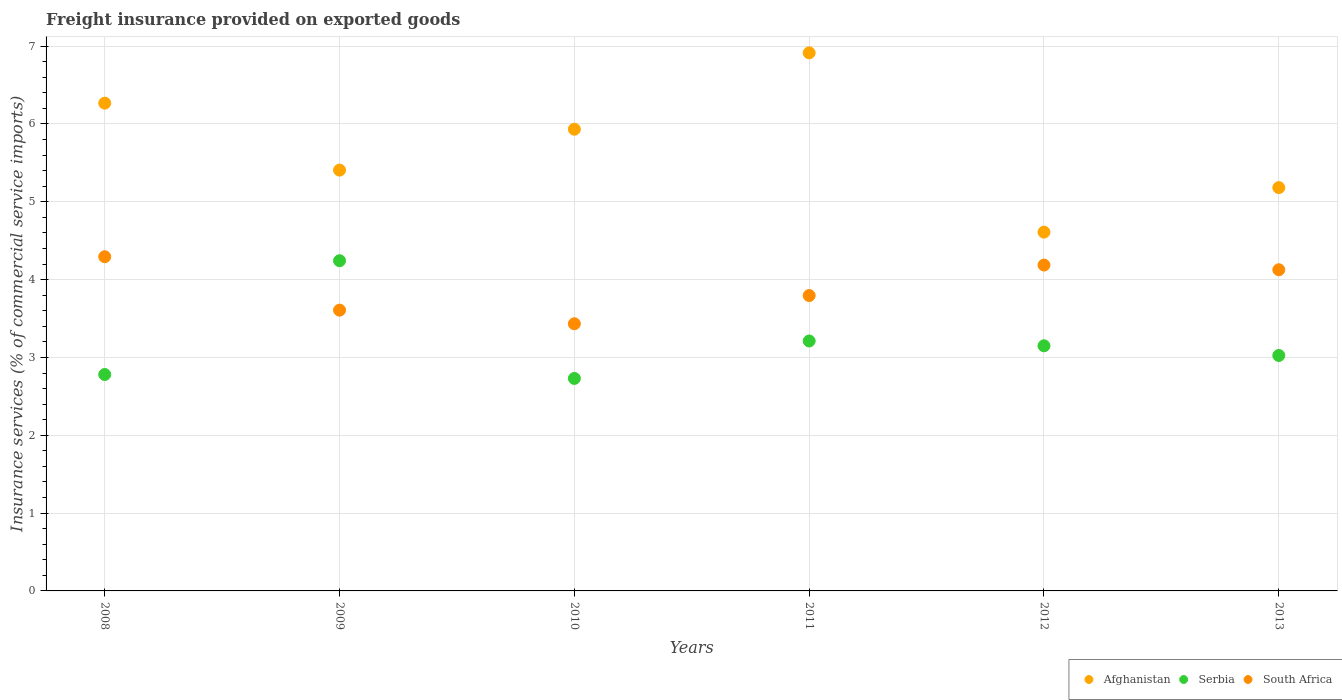What is the freight insurance provided on exported goods in Serbia in 2013?
Your response must be concise. 3.03. Across all years, what is the maximum freight insurance provided on exported goods in South Africa?
Keep it short and to the point. 4.29. Across all years, what is the minimum freight insurance provided on exported goods in South Africa?
Your response must be concise. 3.43. In which year was the freight insurance provided on exported goods in Afghanistan maximum?
Make the answer very short. 2011. What is the total freight insurance provided on exported goods in Serbia in the graph?
Your response must be concise. 19.14. What is the difference between the freight insurance provided on exported goods in Afghanistan in 2009 and that in 2011?
Provide a succinct answer. -1.51. What is the difference between the freight insurance provided on exported goods in South Africa in 2012 and the freight insurance provided on exported goods in Afghanistan in 2008?
Give a very brief answer. -2.08. What is the average freight insurance provided on exported goods in Serbia per year?
Offer a terse response. 3.19. In the year 2008, what is the difference between the freight insurance provided on exported goods in Afghanistan and freight insurance provided on exported goods in South Africa?
Your response must be concise. 1.97. What is the ratio of the freight insurance provided on exported goods in Afghanistan in 2011 to that in 2013?
Your answer should be compact. 1.33. What is the difference between the highest and the second highest freight insurance provided on exported goods in Serbia?
Offer a very short reply. 1.03. What is the difference between the highest and the lowest freight insurance provided on exported goods in South Africa?
Your answer should be compact. 0.86. Is it the case that in every year, the sum of the freight insurance provided on exported goods in Afghanistan and freight insurance provided on exported goods in Serbia  is greater than the freight insurance provided on exported goods in South Africa?
Keep it short and to the point. Yes. Does the freight insurance provided on exported goods in Serbia monotonically increase over the years?
Offer a very short reply. No. Is the freight insurance provided on exported goods in Afghanistan strictly less than the freight insurance provided on exported goods in Serbia over the years?
Give a very brief answer. No. How many dotlines are there?
Ensure brevity in your answer.  3. What is the difference between two consecutive major ticks on the Y-axis?
Provide a succinct answer. 1. Does the graph contain grids?
Keep it short and to the point. Yes. How are the legend labels stacked?
Give a very brief answer. Horizontal. What is the title of the graph?
Offer a very short reply. Freight insurance provided on exported goods. Does "Paraguay" appear as one of the legend labels in the graph?
Ensure brevity in your answer.  No. What is the label or title of the Y-axis?
Ensure brevity in your answer.  Insurance services (% of commercial service imports). What is the Insurance services (% of commercial service imports) of Afghanistan in 2008?
Offer a terse response. 6.27. What is the Insurance services (% of commercial service imports) in Serbia in 2008?
Ensure brevity in your answer.  2.78. What is the Insurance services (% of commercial service imports) of South Africa in 2008?
Your response must be concise. 4.29. What is the Insurance services (% of commercial service imports) of Afghanistan in 2009?
Give a very brief answer. 5.41. What is the Insurance services (% of commercial service imports) of Serbia in 2009?
Provide a succinct answer. 4.24. What is the Insurance services (% of commercial service imports) of South Africa in 2009?
Your response must be concise. 3.61. What is the Insurance services (% of commercial service imports) of Afghanistan in 2010?
Ensure brevity in your answer.  5.93. What is the Insurance services (% of commercial service imports) of Serbia in 2010?
Provide a short and direct response. 2.73. What is the Insurance services (% of commercial service imports) of South Africa in 2010?
Keep it short and to the point. 3.43. What is the Insurance services (% of commercial service imports) of Afghanistan in 2011?
Offer a terse response. 6.91. What is the Insurance services (% of commercial service imports) in Serbia in 2011?
Give a very brief answer. 3.21. What is the Insurance services (% of commercial service imports) in South Africa in 2011?
Your answer should be very brief. 3.8. What is the Insurance services (% of commercial service imports) in Afghanistan in 2012?
Provide a short and direct response. 4.61. What is the Insurance services (% of commercial service imports) of Serbia in 2012?
Give a very brief answer. 3.15. What is the Insurance services (% of commercial service imports) in South Africa in 2012?
Your answer should be compact. 4.19. What is the Insurance services (% of commercial service imports) in Afghanistan in 2013?
Give a very brief answer. 5.18. What is the Insurance services (% of commercial service imports) in Serbia in 2013?
Your answer should be very brief. 3.03. What is the Insurance services (% of commercial service imports) of South Africa in 2013?
Provide a short and direct response. 4.13. Across all years, what is the maximum Insurance services (% of commercial service imports) in Afghanistan?
Your answer should be very brief. 6.91. Across all years, what is the maximum Insurance services (% of commercial service imports) in Serbia?
Provide a short and direct response. 4.24. Across all years, what is the maximum Insurance services (% of commercial service imports) of South Africa?
Make the answer very short. 4.29. Across all years, what is the minimum Insurance services (% of commercial service imports) in Afghanistan?
Offer a terse response. 4.61. Across all years, what is the minimum Insurance services (% of commercial service imports) of Serbia?
Your answer should be compact. 2.73. Across all years, what is the minimum Insurance services (% of commercial service imports) in South Africa?
Provide a short and direct response. 3.43. What is the total Insurance services (% of commercial service imports) in Afghanistan in the graph?
Make the answer very short. 34.31. What is the total Insurance services (% of commercial service imports) in Serbia in the graph?
Your response must be concise. 19.14. What is the total Insurance services (% of commercial service imports) of South Africa in the graph?
Provide a succinct answer. 23.44. What is the difference between the Insurance services (% of commercial service imports) of Afghanistan in 2008 and that in 2009?
Provide a succinct answer. 0.86. What is the difference between the Insurance services (% of commercial service imports) in Serbia in 2008 and that in 2009?
Provide a succinct answer. -1.46. What is the difference between the Insurance services (% of commercial service imports) of South Africa in 2008 and that in 2009?
Your response must be concise. 0.69. What is the difference between the Insurance services (% of commercial service imports) in Afghanistan in 2008 and that in 2010?
Your answer should be compact. 0.34. What is the difference between the Insurance services (% of commercial service imports) of Serbia in 2008 and that in 2010?
Provide a short and direct response. 0.05. What is the difference between the Insurance services (% of commercial service imports) in South Africa in 2008 and that in 2010?
Provide a succinct answer. 0.86. What is the difference between the Insurance services (% of commercial service imports) of Afghanistan in 2008 and that in 2011?
Ensure brevity in your answer.  -0.65. What is the difference between the Insurance services (% of commercial service imports) in Serbia in 2008 and that in 2011?
Your response must be concise. -0.43. What is the difference between the Insurance services (% of commercial service imports) in South Africa in 2008 and that in 2011?
Your answer should be compact. 0.5. What is the difference between the Insurance services (% of commercial service imports) of Afghanistan in 2008 and that in 2012?
Your answer should be compact. 1.66. What is the difference between the Insurance services (% of commercial service imports) of Serbia in 2008 and that in 2012?
Your answer should be very brief. -0.37. What is the difference between the Insurance services (% of commercial service imports) in South Africa in 2008 and that in 2012?
Make the answer very short. 0.11. What is the difference between the Insurance services (% of commercial service imports) of Afghanistan in 2008 and that in 2013?
Give a very brief answer. 1.09. What is the difference between the Insurance services (% of commercial service imports) of Serbia in 2008 and that in 2013?
Your response must be concise. -0.24. What is the difference between the Insurance services (% of commercial service imports) of South Africa in 2008 and that in 2013?
Ensure brevity in your answer.  0.17. What is the difference between the Insurance services (% of commercial service imports) in Afghanistan in 2009 and that in 2010?
Your answer should be compact. -0.53. What is the difference between the Insurance services (% of commercial service imports) in Serbia in 2009 and that in 2010?
Ensure brevity in your answer.  1.51. What is the difference between the Insurance services (% of commercial service imports) of South Africa in 2009 and that in 2010?
Your answer should be compact. 0.17. What is the difference between the Insurance services (% of commercial service imports) of Afghanistan in 2009 and that in 2011?
Provide a short and direct response. -1.51. What is the difference between the Insurance services (% of commercial service imports) of Serbia in 2009 and that in 2011?
Offer a terse response. 1.03. What is the difference between the Insurance services (% of commercial service imports) in South Africa in 2009 and that in 2011?
Provide a succinct answer. -0.19. What is the difference between the Insurance services (% of commercial service imports) in Afghanistan in 2009 and that in 2012?
Your answer should be compact. 0.8. What is the difference between the Insurance services (% of commercial service imports) of Serbia in 2009 and that in 2012?
Make the answer very short. 1.09. What is the difference between the Insurance services (% of commercial service imports) in South Africa in 2009 and that in 2012?
Your answer should be compact. -0.58. What is the difference between the Insurance services (% of commercial service imports) of Afghanistan in 2009 and that in 2013?
Make the answer very short. 0.23. What is the difference between the Insurance services (% of commercial service imports) in Serbia in 2009 and that in 2013?
Keep it short and to the point. 1.22. What is the difference between the Insurance services (% of commercial service imports) of South Africa in 2009 and that in 2013?
Your answer should be very brief. -0.52. What is the difference between the Insurance services (% of commercial service imports) in Afghanistan in 2010 and that in 2011?
Your answer should be very brief. -0.98. What is the difference between the Insurance services (% of commercial service imports) of Serbia in 2010 and that in 2011?
Your answer should be compact. -0.48. What is the difference between the Insurance services (% of commercial service imports) in South Africa in 2010 and that in 2011?
Offer a very short reply. -0.36. What is the difference between the Insurance services (% of commercial service imports) in Afghanistan in 2010 and that in 2012?
Your answer should be compact. 1.32. What is the difference between the Insurance services (% of commercial service imports) of Serbia in 2010 and that in 2012?
Your answer should be compact. -0.42. What is the difference between the Insurance services (% of commercial service imports) of South Africa in 2010 and that in 2012?
Offer a very short reply. -0.75. What is the difference between the Insurance services (% of commercial service imports) in Afghanistan in 2010 and that in 2013?
Make the answer very short. 0.75. What is the difference between the Insurance services (% of commercial service imports) of Serbia in 2010 and that in 2013?
Give a very brief answer. -0.3. What is the difference between the Insurance services (% of commercial service imports) in South Africa in 2010 and that in 2013?
Offer a very short reply. -0.69. What is the difference between the Insurance services (% of commercial service imports) in Afghanistan in 2011 and that in 2012?
Make the answer very short. 2.3. What is the difference between the Insurance services (% of commercial service imports) of Serbia in 2011 and that in 2012?
Provide a succinct answer. 0.06. What is the difference between the Insurance services (% of commercial service imports) in South Africa in 2011 and that in 2012?
Your answer should be very brief. -0.39. What is the difference between the Insurance services (% of commercial service imports) of Afghanistan in 2011 and that in 2013?
Provide a succinct answer. 1.73. What is the difference between the Insurance services (% of commercial service imports) of Serbia in 2011 and that in 2013?
Give a very brief answer. 0.19. What is the difference between the Insurance services (% of commercial service imports) of South Africa in 2011 and that in 2013?
Your response must be concise. -0.33. What is the difference between the Insurance services (% of commercial service imports) of Afghanistan in 2012 and that in 2013?
Ensure brevity in your answer.  -0.57. What is the difference between the Insurance services (% of commercial service imports) in Serbia in 2012 and that in 2013?
Offer a very short reply. 0.12. What is the difference between the Insurance services (% of commercial service imports) of South Africa in 2012 and that in 2013?
Give a very brief answer. 0.06. What is the difference between the Insurance services (% of commercial service imports) of Afghanistan in 2008 and the Insurance services (% of commercial service imports) of Serbia in 2009?
Provide a short and direct response. 2.02. What is the difference between the Insurance services (% of commercial service imports) in Afghanistan in 2008 and the Insurance services (% of commercial service imports) in South Africa in 2009?
Ensure brevity in your answer.  2.66. What is the difference between the Insurance services (% of commercial service imports) of Serbia in 2008 and the Insurance services (% of commercial service imports) of South Africa in 2009?
Provide a short and direct response. -0.83. What is the difference between the Insurance services (% of commercial service imports) of Afghanistan in 2008 and the Insurance services (% of commercial service imports) of Serbia in 2010?
Offer a terse response. 3.54. What is the difference between the Insurance services (% of commercial service imports) in Afghanistan in 2008 and the Insurance services (% of commercial service imports) in South Africa in 2010?
Your answer should be very brief. 2.83. What is the difference between the Insurance services (% of commercial service imports) of Serbia in 2008 and the Insurance services (% of commercial service imports) of South Africa in 2010?
Provide a succinct answer. -0.65. What is the difference between the Insurance services (% of commercial service imports) of Afghanistan in 2008 and the Insurance services (% of commercial service imports) of Serbia in 2011?
Keep it short and to the point. 3.06. What is the difference between the Insurance services (% of commercial service imports) of Afghanistan in 2008 and the Insurance services (% of commercial service imports) of South Africa in 2011?
Keep it short and to the point. 2.47. What is the difference between the Insurance services (% of commercial service imports) of Serbia in 2008 and the Insurance services (% of commercial service imports) of South Africa in 2011?
Your answer should be compact. -1.01. What is the difference between the Insurance services (% of commercial service imports) of Afghanistan in 2008 and the Insurance services (% of commercial service imports) of Serbia in 2012?
Keep it short and to the point. 3.12. What is the difference between the Insurance services (% of commercial service imports) of Afghanistan in 2008 and the Insurance services (% of commercial service imports) of South Africa in 2012?
Your response must be concise. 2.08. What is the difference between the Insurance services (% of commercial service imports) in Serbia in 2008 and the Insurance services (% of commercial service imports) in South Africa in 2012?
Provide a short and direct response. -1.41. What is the difference between the Insurance services (% of commercial service imports) in Afghanistan in 2008 and the Insurance services (% of commercial service imports) in Serbia in 2013?
Ensure brevity in your answer.  3.24. What is the difference between the Insurance services (% of commercial service imports) in Afghanistan in 2008 and the Insurance services (% of commercial service imports) in South Africa in 2013?
Your answer should be compact. 2.14. What is the difference between the Insurance services (% of commercial service imports) in Serbia in 2008 and the Insurance services (% of commercial service imports) in South Africa in 2013?
Make the answer very short. -1.35. What is the difference between the Insurance services (% of commercial service imports) of Afghanistan in 2009 and the Insurance services (% of commercial service imports) of Serbia in 2010?
Your answer should be very brief. 2.68. What is the difference between the Insurance services (% of commercial service imports) in Afghanistan in 2009 and the Insurance services (% of commercial service imports) in South Africa in 2010?
Ensure brevity in your answer.  1.97. What is the difference between the Insurance services (% of commercial service imports) of Serbia in 2009 and the Insurance services (% of commercial service imports) of South Africa in 2010?
Your response must be concise. 0.81. What is the difference between the Insurance services (% of commercial service imports) in Afghanistan in 2009 and the Insurance services (% of commercial service imports) in Serbia in 2011?
Your response must be concise. 2.2. What is the difference between the Insurance services (% of commercial service imports) in Afghanistan in 2009 and the Insurance services (% of commercial service imports) in South Africa in 2011?
Your response must be concise. 1.61. What is the difference between the Insurance services (% of commercial service imports) of Serbia in 2009 and the Insurance services (% of commercial service imports) of South Africa in 2011?
Ensure brevity in your answer.  0.45. What is the difference between the Insurance services (% of commercial service imports) of Afghanistan in 2009 and the Insurance services (% of commercial service imports) of Serbia in 2012?
Offer a terse response. 2.26. What is the difference between the Insurance services (% of commercial service imports) of Afghanistan in 2009 and the Insurance services (% of commercial service imports) of South Africa in 2012?
Make the answer very short. 1.22. What is the difference between the Insurance services (% of commercial service imports) of Serbia in 2009 and the Insurance services (% of commercial service imports) of South Africa in 2012?
Offer a terse response. 0.06. What is the difference between the Insurance services (% of commercial service imports) in Afghanistan in 2009 and the Insurance services (% of commercial service imports) in Serbia in 2013?
Give a very brief answer. 2.38. What is the difference between the Insurance services (% of commercial service imports) of Afghanistan in 2009 and the Insurance services (% of commercial service imports) of South Africa in 2013?
Keep it short and to the point. 1.28. What is the difference between the Insurance services (% of commercial service imports) in Serbia in 2009 and the Insurance services (% of commercial service imports) in South Africa in 2013?
Offer a terse response. 0.12. What is the difference between the Insurance services (% of commercial service imports) of Afghanistan in 2010 and the Insurance services (% of commercial service imports) of Serbia in 2011?
Offer a very short reply. 2.72. What is the difference between the Insurance services (% of commercial service imports) in Afghanistan in 2010 and the Insurance services (% of commercial service imports) in South Africa in 2011?
Your response must be concise. 2.14. What is the difference between the Insurance services (% of commercial service imports) in Serbia in 2010 and the Insurance services (% of commercial service imports) in South Africa in 2011?
Give a very brief answer. -1.07. What is the difference between the Insurance services (% of commercial service imports) of Afghanistan in 2010 and the Insurance services (% of commercial service imports) of Serbia in 2012?
Provide a short and direct response. 2.78. What is the difference between the Insurance services (% of commercial service imports) in Afghanistan in 2010 and the Insurance services (% of commercial service imports) in South Africa in 2012?
Your answer should be compact. 1.75. What is the difference between the Insurance services (% of commercial service imports) of Serbia in 2010 and the Insurance services (% of commercial service imports) of South Africa in 2012?
Your response must be concise. -1.46. What is the difference between the Insurance services (% of commercial service imports) of Afghanistan in 2010 and the Insurance services (% of commercial service imports) of Serbia in 2013?
Provide a succinct answer. 2.91. What is the difference between the Insurance services (% of commercial service imports) of Afghanistan in 2010 and the Insurance services (% of commercial service imports) of South Africa in 2013?
Provide a succinct answer. 1.81. What is the difference between the Insurance services (% of commercial service imports) of Serbia in 2010 and the Insurance services (% of commercial service imports) of South Africa in 2013?
Keep it short and to the point. -1.4. What is the difference between the Insurance services (% of commercial service imports) in Afghanistan in 2011 and the Insurance services (% of commercial service imports) in Serbia in 2012?
Your answer should be very brief. 3.76. What is the difference between the Insurance services (% of commercial service imports) of Afghanistan in 2011 and the Insurance services (% of commercial service imports) of South Africa in 2012?
Provide a succinct answer. 2.73. What is the difference between the Insurance services (% of commercial service imports) in Serbia in 2011 and the Insurance services (% of commercial service imports) in South Africa in 2012?
Ensure brevity in your answer.  -0.98. What is the difference between the Insurance services (% of commercial service imports) of Afghanistan in 2011 and the Insurance services (% of commercial service imports) of Serbia in 2013?
Provide a short and direct response. 3.89. What is the difference between the Insurance services (% of commercial service imports) in Afghanistan in 2011 and the Insurance services (% of commercial service imports) in South Africa in 2013?
Ensure brevity in your answer.  2.79. What is the difference between the Insurance services (% of commercial service imports) in Serbia in 2011 and the Insurance services (% of commercial service imports) in South Africa in 2013?
Your response must be concise. -0.92. What is the difference between the Insurance services (% of commercial service imports) of Afghanistan in 2012 and the Insurance services (% of commercial service imports) of Serbia in 2013?
Your response must be concise. 1.58. What is the difference between the Insurance services (% of commercial service imports) in Afghanistan in 2012 and the Insurance services (% of commercial service imports) in South Africa in 2013?
Make the answer very short. 0.48. What is the difference between the Insurance services (% of commercial service imports) of Serbia in 2012 and the Insurance services (% of commercial service imports) of South Africa in 2013?
Give a very brief answer. -0.98. What is the average Insurance services (% of commercial service imports) in Afghanistan per year?
Offer a terse response. 5.72. What is the average Insurance services (% of commercial service imports) of Serbia per year?
Your response must be concise. 3.19. What is the average Insurance services (% of commercial service imports) of South Africa per year?
Keep it short and to the point. 3.91. In the year 2008, what is the difference between the Insurance services (% of commercial service imports) in Afghanistan and Insurance services (% of commercial service imports) in Serbia?
Your answer should be very brief. 3.49. In the year 2008, what is the difference between the Insurance services (% of commercial service imports) of Afghanistan and Insurance services (% of commercial service imports) of South Africa?
Ensure brevity in your answer.  1.97. In the year 2008, what is the difference between the Insurance services (% of commercial service imports) in Serbia and Insurance services (% of commercial service imports) in South Africa?
Your answer should be very brief. -1.51. In the year 2009, what is the difference between the Insurance services (% of commercial service imports) of Afghanistan and Insurance services (% of commercial service imports) of Serbia?
Provide a succinct answer. 1.16. In the year 2009, what is the difference between the Insurance services (% of commercial service imports) of Afghanistan and Insurance services (% of commercial service imports) of South Africa?
Give a very brief answer. 1.8. In the year 2009, what is the difference between the Insurance services (% of commercial service imports) in Serbia and Insurance services (% of commercial service imports) in South Africa?
Offer a very short reply. 0.64. In the year 2010, what is the difference between the Insurance services (% of commercial service imports) of Afghanistan and Insurance services (% of commercial service imports) of Serbia?
Keep it short and to the point. 3.2. In the year 2010, what is the difference between the Insurance services (% of commercial service imports) of Afghanistan and Insurance services (% of commercial service imports) of South Africa?
Make the answer very short. 2.5. In the year 2010, what is the difference between the Insurance services (% of commercial service imports) of Serbia and Insurance services (% of commercial service imports) of South Africa?
Keep it short and to the point. -0.7. In the year 2011, what is the difference between the Insurance services (% of commercial service imports) of Afghanistan and Insurance services (% of commercial service imports) of Serbia?
Provide a succinct answer. 3.7. In the year 2011, what is the difference between the Insurance services (% of commercial service imports) of Afghanistan and Insurance services (% of commercial service imports) of South Africa?
Provide a succinct answer. 3.12. In the year 2011, what is the difference between the Insurance services (% of commercial service imports) in Serbia and Insurance services (% of commercial service imports) in South Africa?
Offer a very short reply. -0.58. In the year 2012, what is the difference between the Insurance services (% of commercial service imports) of Afghanistan and Insurance services (% of commercial service imports) of Serbia?
Your answer should be very brief. 1.46. In the year 2012, what is the difference between the Insurance services (% of commercial service imports) of Afghanistan and Insurance services (% of commercial service imports) of South Africa?
Your answer should be very brief. 0.42. In the year 2012, what is the difference between the Insurance services (% of commercial service imports) of Serbia and Insurance services (% of commercial service imports) of South Africa?
Your answer should be compact. -1.04. In the year 2013, what is the difference between the Insurance services (% of commercial service imports) in Afghanistan and Insurance services (% of commercial service imports) in Serbia?
Your response must be concise. 2.16. In the year 2013, what is the difference between the Insurance services (% of commercial service imports) of Afghanistan and Insurance services (% of commercial service imports) of South Africa?
Provide a succinct answer. 1.06. In the year 2013, what is the difference between the Insurance services (% of commercial service imports) of Serbia and Insurance services (% of commercial service imports) of South Africa?
Your answer should be very brief. -1.1. What is the ratio of the Insurance services (% of commercial service imports) in Afghanistan in 2008 to that in 2009?
Your response must be concise. 1.16. What is the ratio of the Insurance services (% of commercial service imports) of Serbia in 2008 to that in 2009?
Your answer should be very brief. 0.66. What is the ratio of the Insurance services (% of commercial service imports) of South Africa in 2008 to that in 2009?
Your answer should be very brief. 1.19. What is the ratio of the Insurance services (% of commercial service imports) of Afghanistan in 2008 to that in 2010?
Keep it short and to the point. 1.06. What is the ratio of the Insurance services (% of commercial service imports) in Serbia in 2008 to that in 2010?
Your answer should be very brief. 1.02. What is the ratio of the Insurance services (% of commercial service imports) in South Africa in 2008 to that in 2010?
Ensure brevity in your answer.  1.25. What is the ratio of the Insurance services (% of commercial service imports) of Afghanistan in 2008 to that in 2011?
Provide a succinct answer. 0.91. What is the ratio of the Insurance services (% of commercial service imports) of Serbia in 2008 to that in 2011?
Make the answer very short. 0.87. What is the ratio of the Insurance services (% of commercial service imports) in South Africa in 2008 to that in 2011?
Provide a short and direct response. 1.13. What is the ratio of the Insurance services (% of commercial service imports) of Afghanistan in 2008 to that in 2012?
Offer a terse response. 1.36. What is the ratio of the Insurance services (% of commercial service imports) of Serbia in 2008 to that in 2012?
Give a very brief answer. 0.88. What is the ratio of the Insurance services (% of commercial service imports) of South Africa in 2008 to that in 2012?
Ensure brevity in your answer.  1.03. What is the ratio of the Insurance services (% of commercial service imports) of Afghanistan in 2008 to that in 2013?
Provide a succinct answer. 1.21. What is the ratio of the Insurance services (% of commercial service imports) in Serbia in 2008 to that in 2013?
Offer a terse response. 0.92. What is the ratio of the Insurance services (% of commercial service imports) in South Africa in 2008 to that in 2013?
Your answer should be very brief. 1.04. What is the ratio of the Insurance services (% of commercial service imports) of Afghanistan in 2009 to that in 2010?
Offer a terse response. 0.91. What is the ratio of the Insurance services (% of commercial service imports) of Serbia in 2009 to that in 2010?
Your response must be concise. 1.55. What is the ratio of the Insurance services (% of commercial service imports) of South Africa in 2009 to that in 2010?
Ensure brevity in your answer.  1.05. What is the ratio of the Insurance services (% of commercial service imports) in Afghanistan in 2009 to that in 2011?
Offer a very short reply. 0.78. What is the ratio of the Insurance services (% of commercial service imports) of Serbia in 2009 to that in 2011?
Provide a short and direct response. 1.32. What is the ratio of the Insurance services (% of commercial service imports) in South Africa in 2009 to that in 2011?
Offer a terse response. 0.95. What is the ratio of the Insurance services (% of commercial service imports) of Afghanistan in 2009 to that in 2012?
Make the answer very short. 1.17. What is the ratio of the Insurance services (% of commercial service imports) in Serbia in 2009 to that in 2012?
Offer a terse response. 1.35. What is the ratio of the Insurance services (% of commercial service imports) of South Africa in 2009 to that in 2012?
Give a very brief answer. 0.86. What is the ratio of the Insurance services (% of commercial service imports) in Afghanistan in 2009 to that in 2013?
Your answer should be very brief. 1.04. What is the ratio of the Insurance services (% of commercial service imports) in Serbia in 2009 to that in 2013?
Your response must be concise. 1.4. What is the ratio of the Insurance services (% of commercial service imports) in South Africa in 2009 to that in 2013?
Ensure brevity in your answer.  0.87. What is the ratio of the Insurance services (% of commercial service imports) of Afghanistan in 2010 to that in 2011?
Offer a terse response. 0.86. What is the ratio of the Insurance services (% of commercial service imports) in Serbia in 2010 to that in 2011?
Your answer should be very brief. 0.85. What is the ratio of the Insurance services (% of commercial service imports) of South Africa in 2010 to that in 2011?
Your response must be concise. 0.9. What is the ratio of the Insurance services (% of commercial service imports) in Afghanistan in 2010 to that in 2012?
Your answer should be compact. 1.29. What is the ratio of the Insurance services (% of commercial service imports) of Serbia in 2010 to that in 2012?
Your answer should be very brief. 0.87. What is the ratio of the Insurance services (% of commercial service imports) of South Africa in 2010 to that in 2012?
Offer a very short reply. 0.82. What is the ratio of the Insurance services (% of commercial service imports) of Afghanistan in 2010 to that in 2013?
Offer a very short reply. 1.14. What is the ratio of the Insurance services (% of commercial service imports) in Serbia in 2010 to that in 2013?
Your response must be concise. 0.9. What is the ratio of the Insurance services (% of commercial service imports) of South Africa in 2010 to that in 2013?
Make the answer very short. 0.83. What is the ratio of the Insurance services (% of commercial service imports) of Afghanistan in 2011 to that in 2012?
Provide a succinct answer. 1.5. What is the ratio of the Insurance services (% of commercial service imports) of Serbia in 2011 to that in 2012?
Your answer should be compact. 1.02. What is the ratio of the Insurance services (% of commercial service imports) in South Africa in 2011 to that in 2012?
Your answer should be very brief. 0.91. What is the ratio of the Insurance services (% of commercial service imports) in Afghanistan in 2011 to that in 2013?
Give a very brief answer. 1.33. What is the ratio of the Insurance services (% of commercial service imports) in Serbia in 2011 to that in 2013?
Your answer should be very brief. 1.06. What is the ratio of the Insurance services (% of commercial service imports) of South Africa in 2011 to that in 2013?
Make the answer very short. 0.92. What is the ratio of the Insurance services (% of commercial service imports) in Afghanistan in 2012 to that in 2013?
Your answer should be compact. 0.89. What is the ratio of the Insurance services (% of commercial service imports) of Serbia in 2012 to that in 2013?
Your answer should be very brief. 1.04. What is the ratio of the Insurance services (% of commercial service imports) of South Africa in 2012 to that in 2013?
Your response must be concise. 1.01. What is the difference between the highest and the second highest Insurance services (% of commercial service imports) in Afghanistan?
Your answer should be very brief. 0.65. What is the difference between the highest and the second highest Insurance services (% of commercial service imports) in Serbia?
Your response must be concise. 1.03. What is the difference between the highest and the second highest Insurance services (% of commercial service imports) in South Africa?
Your answer should be compact. 0.11. What is the difference between the highest and the lowest Insurance services (% of commercial service imports) in Afghanistan?
Your response must be concise. 2.3. What is the difference between the highest and the lowest Insurance services (% of commercial service imports) of Serbia?
Your answer should be compact. 1.51. What is the difference between the highest and the lowest Insurance services (% of commercial service imports) of South Africa?
Your answer should be compact. 0.86. 